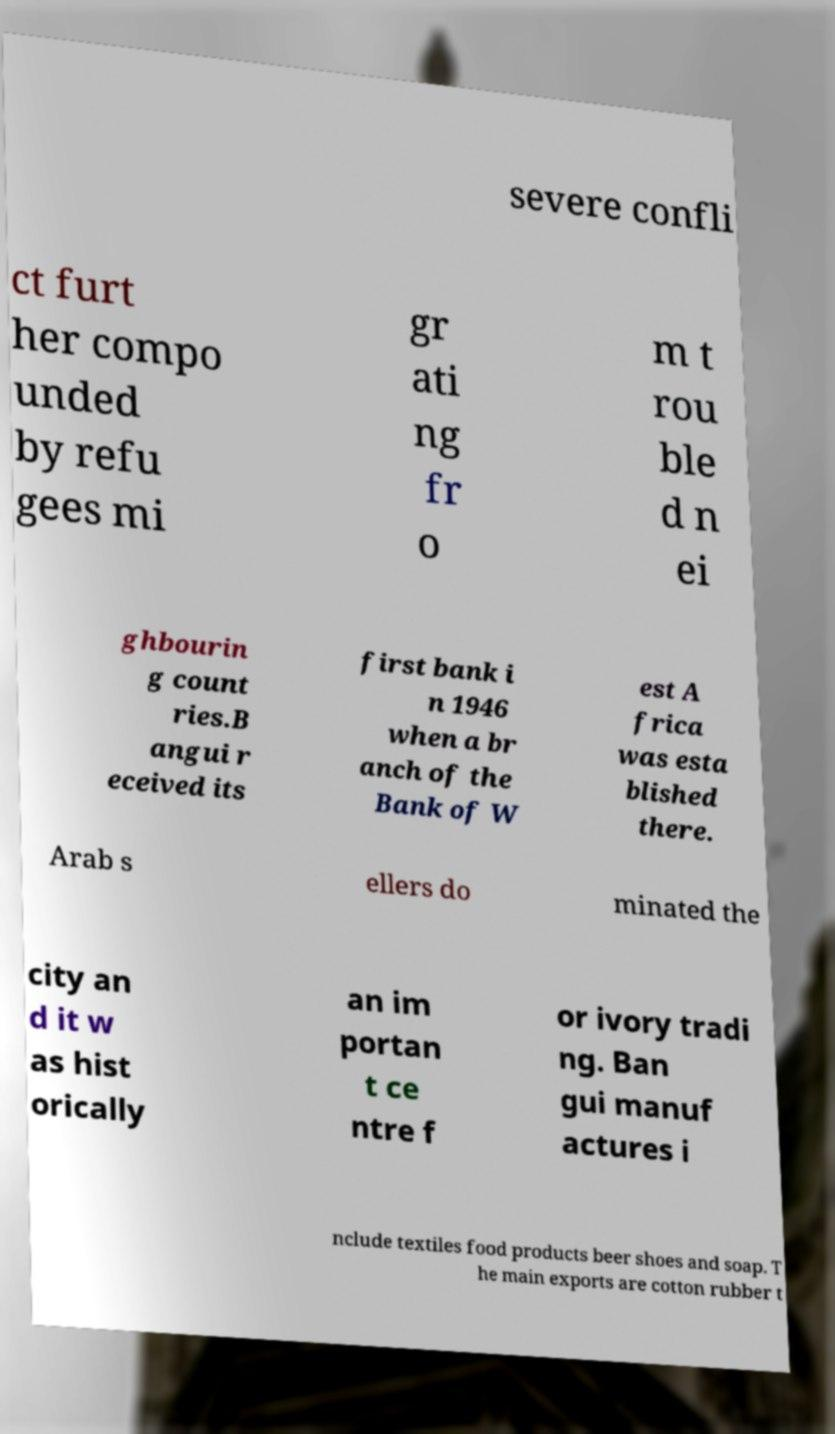There's text embedded in this image that I need extracted. Can you transcribe it verbatim? severe confli ct furt her compo unded by refu gees mi gr ati ng fr o m t rou ble d n ei ghbourin g count ries.B angui r eceived its first bank i n 1946 when a br anch of the Bank of W est A frica was esta blished there. Arab s ellers do minated the city an d it w as hist orically an im portan t ce ntre f or ivory tradi ng. Ban gui manuf actures i nclude textiles food products beer shoes and soap. T he main exports are cotton rubber t 